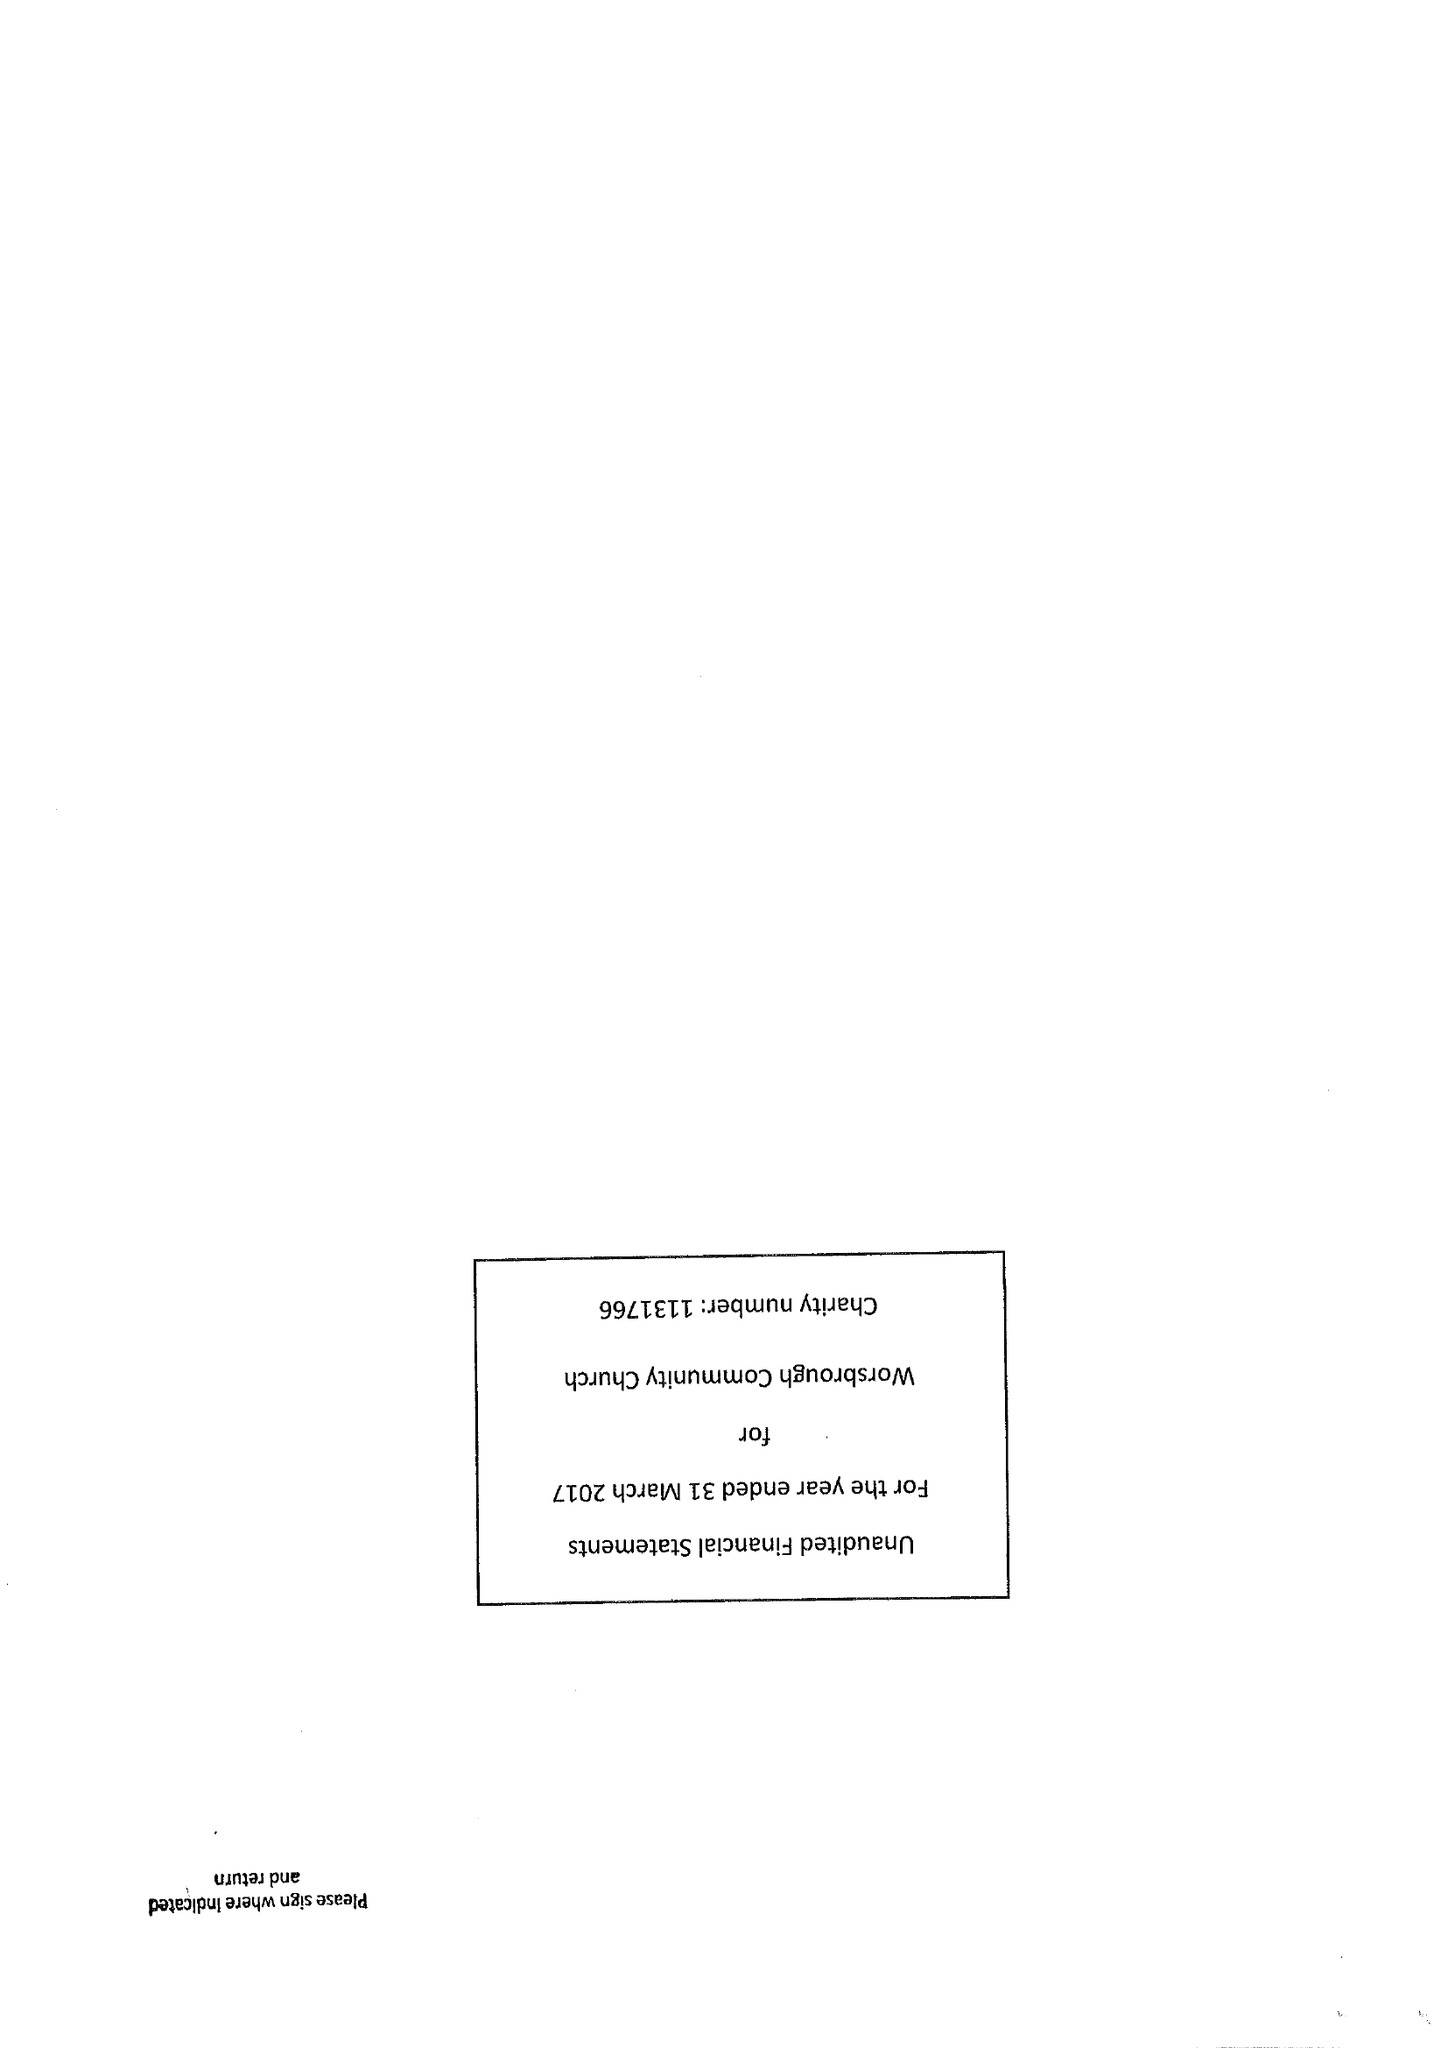What is the value for the address__street_line?
Answer the question using a single word or phrase. HIGH STREET 